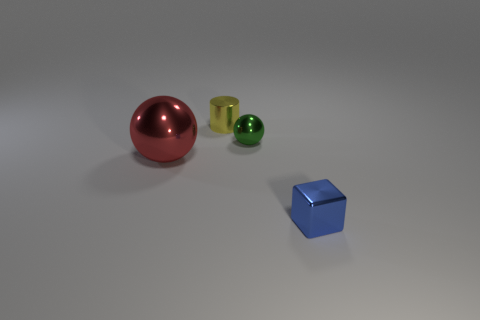There is a large red object on the left side of the small sphere; how many big spheres are in front of it?
Your answer should be very brief. 0. Is the number of yellow metal things that are in front of the blue shiny thing less than the number of small green objects?
Provide a succinct answer. Yes. There is a metal thing behind the green shiny thing that is in front of the metal cylinder; is there a yellow shiny cylinder that is in front of it?
Ensure brevity in your answer.  No. Is the tiny yellow cylinder made of the same material as the thing in front of the large red shiny thing?
Provide a short and direct response. Yes. There is a metallic ball that is in front of the metal sphere that is right of the tiny metal cylinder; what color is it?
Your answer should be compact. Red. Is there a metal thing that has the same color as the small sphere?
Your response must be concise. No. There is a shiny sphere that is to the right of the sphere in front of the sphere on the right side of the large red thing; what size is it?
Provide a succinct answer. Small. Do the yellow object and the object that is on the left side of the yellow metal object have the same shape?
Provide a short and direct response. No. What number of other things are the same size as the yellow cylinder?
Offer a terse response. 2. How big is the metal sphere behind the large red sphere?
Provide a succinct answer. Small. 